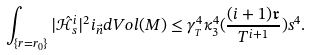<formula> <loc_0><loc_0><loc_500><loc_500>\int _ { \{ r = r _ { 0 } \} } | \hat { \mathcal { H } } ^ { i } _ { s } | ^ { 2 } i _ { \vec { n } } d V o l ( M ) \leq \gamma _ { _ { T } } ^ { 4 } \kappa _ { 3 } ^ { 4 } ( \frac { ( i + 1 ) \mathfrak { r } } { T ^ { i + 1 } } ) s ^ { 4 } .</formula> 